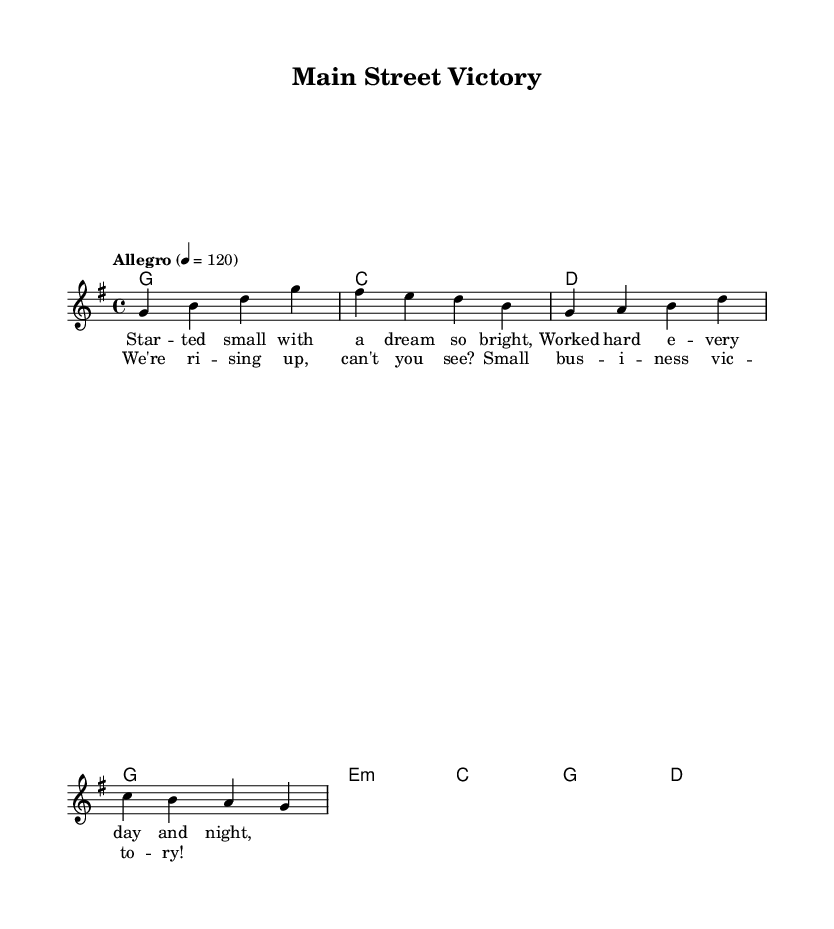What is the key signature of this music? The key signature is G major, which has one sharp (F#). It can be identified by counting the sharps in the key signature section at the beginning of the staff.
Answer: G major What is the time signature of this music? The time signature is 4/4. This can be ascertained from the notation that appears right after the key signature, indicating how many beats are counted in each measure and what note value receives one beat.
Answer: 4/4 What is the tempo marking of this music? The tempo marking is "Allegro". It is noted in the tempo indication at the beginning, indicating a fast and lively pace for the piece.
Answer: Allegro How many measures are in the chorus? The chorus consists of two measures. This can be counted by looking at the notation where the lyrics for the chorus appear and identifying the grouping of the notes.
Answer: Two What type of business does the song celebrate? The song celebrates small business success, as indicated by the theme of the lyrics that discuss hard work and victory in the context of small businesses.
Answer: Small business What genre does this song belong to? The song belongs to the Country Rock genre. This identification comes from the mixture of country influences in both the rhythm and instrumentation typical in the chord progressions and melody.
Answer: Country Rock What is the first lyric of the verse? The first lyric of the verse is "Started small with a dream so bright". This can be found within the lyrical notation aligned with the melody, marking the starting point of the verse.
Answer: Started small with a dream so bright 